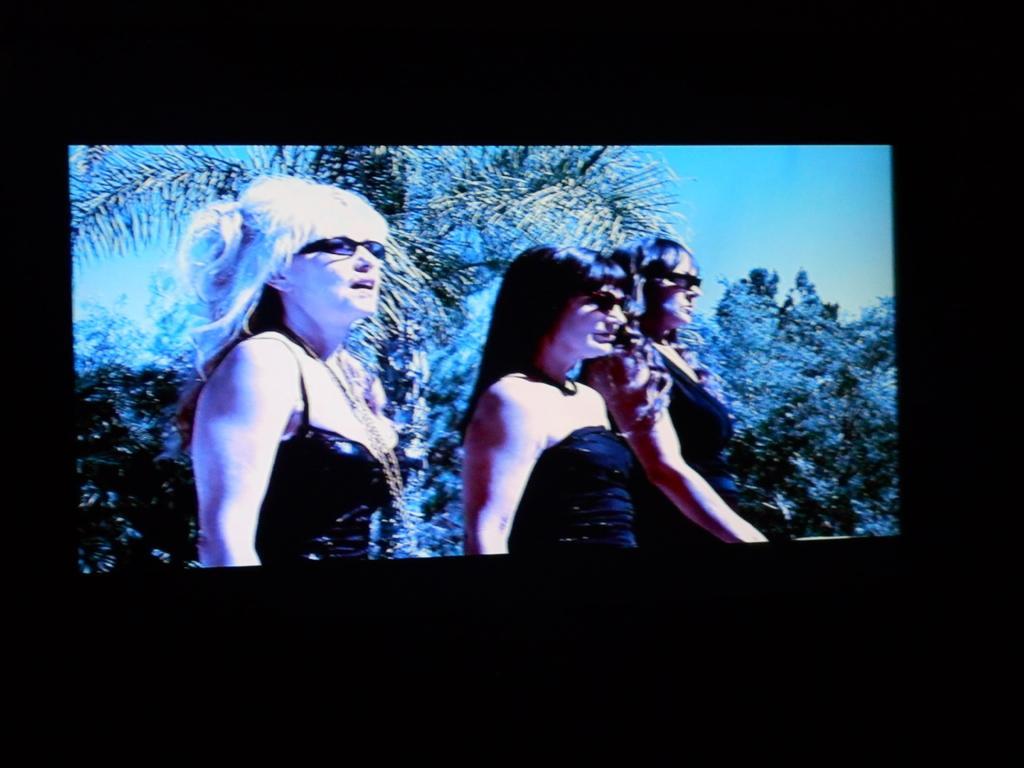Can you describe this image briefly? In this picture, we see three men are standing. Three of them are wearing the goggles. There are trees in the background. At the top, we see the sky. On all the four sides of the picture, it is black in color and this picture is clicked in the dark. 